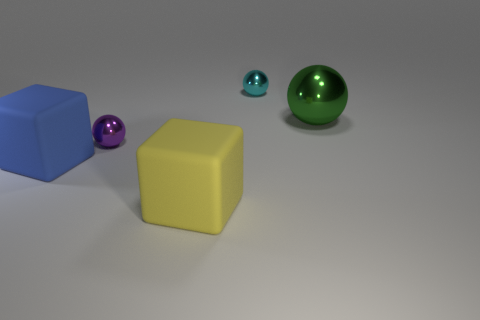Add 4 metal things. How many objects exist? 9 Subtract all balls. How many objects are left? 2 Subtract all blocks. Subtract all big yellow cubes. How many objects are left? 2 Add 4 big spheres. How many big spheres are left? 5 Add 1 large blue cubes. How many large blue cubes exist? 2 Subtract 0 purple cylinders. How many objects are left? 5 